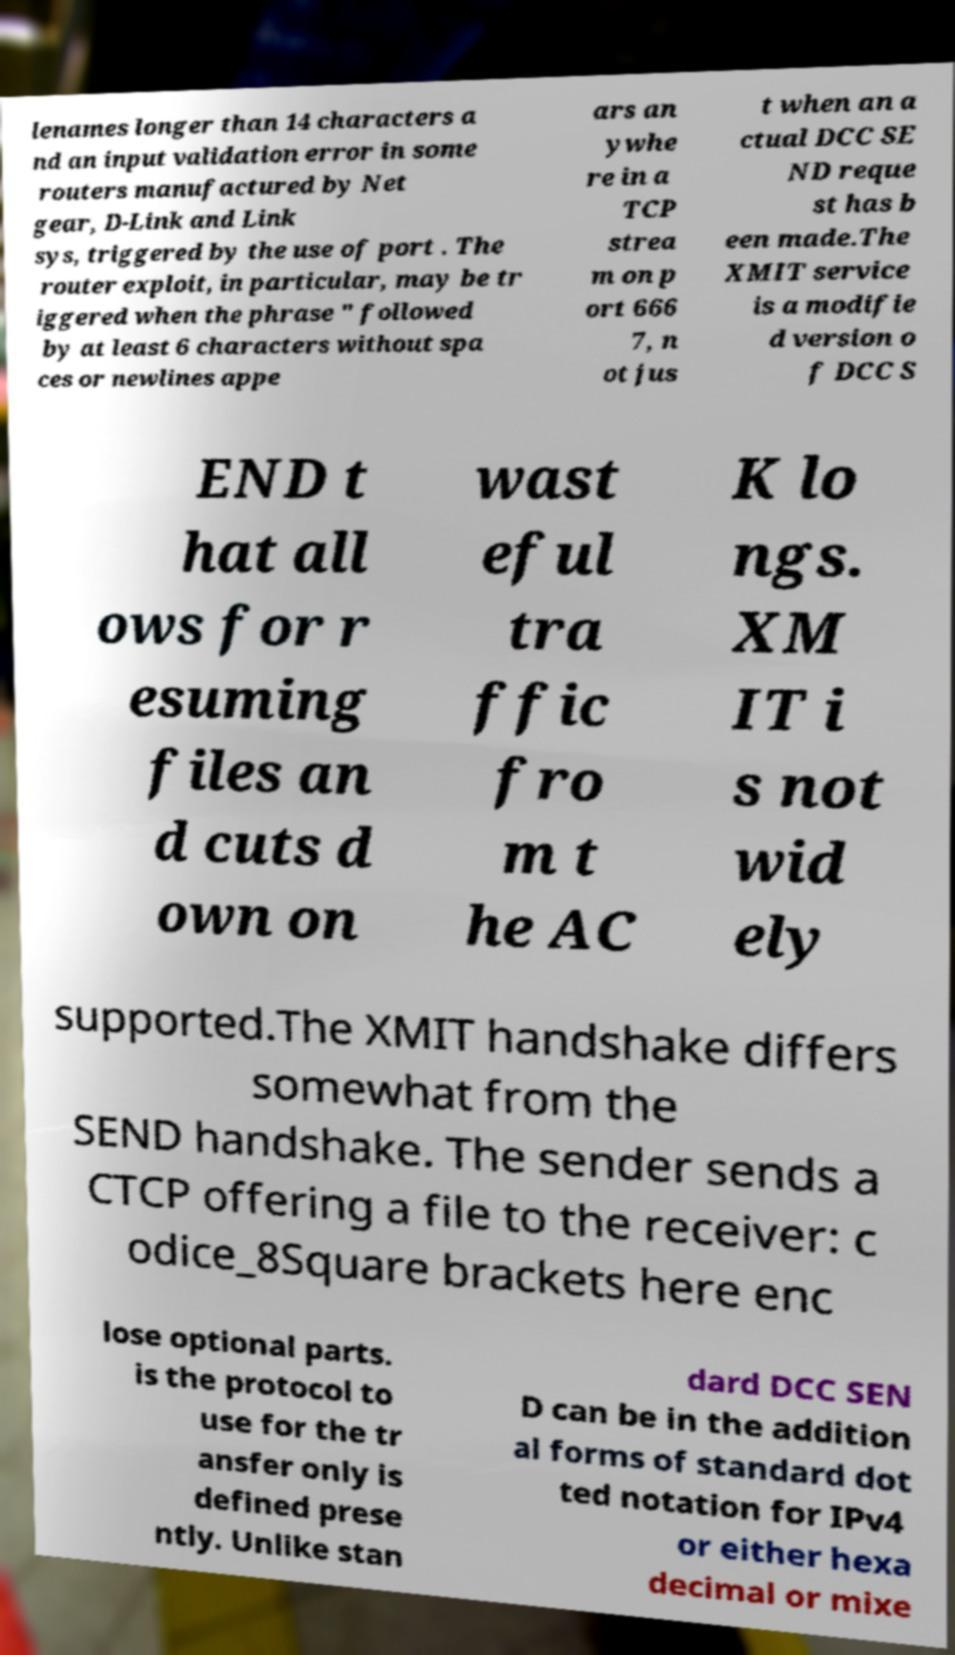Could you assist in decoding the text presented in this image and type it out clearly? lenames longer than 14 characters a nd an input validation error in some routers manufactured by Net gear, D-Link and Link sys, triggered by the use of port . The router exploit, in particular, may be tr iggered when the phrase " followed by at least 6 characters without spa ces or newlines appe ars an ywhe re in a TCP strea m on p ort 666 7, n ot jus t when an a ctual DCC SE ND reque st has b een made.The XMIT service is a modifie d version o f DCC S END t hat all ows for r esuming files an d cuts d own on wast eful tra ffic fro m t he AC K lo ngs. XM IT i s not wid ely supported.The XMIT handshake differs somewhat from the SEND handshake. The sender sends a CTCP offering a file to the receiver: c odice_8Square brackets here enc lose optional parts. is the protocol to use for the tr ansfer only is defined prese ntly. Unlike stan dard DCC SEN D can be in the addition al forms of standard dot ted notation for IPv4 or either hexa decimal or mixe 